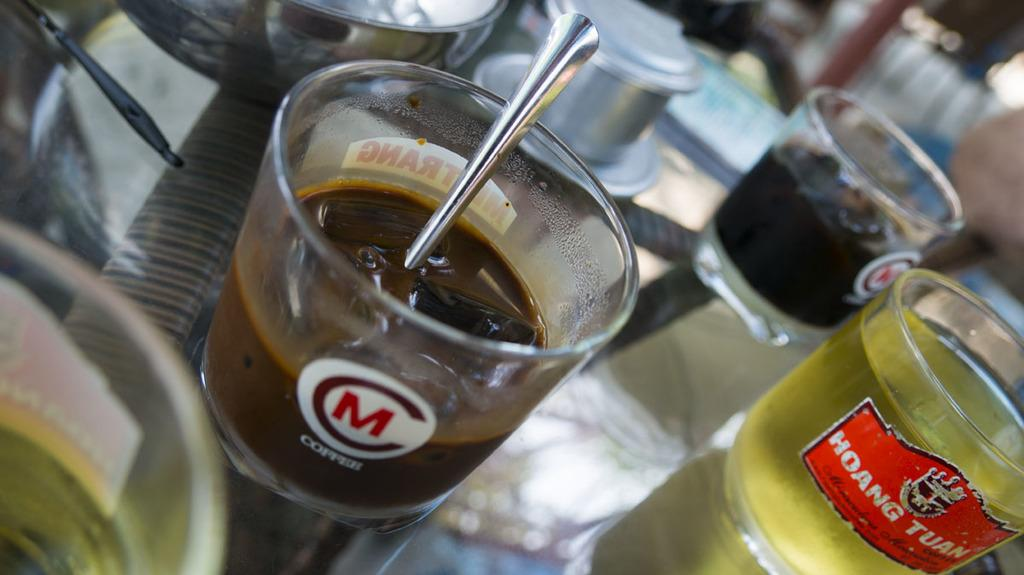<image>
Relay a brief, clear account of the picture shown. Several glasses are on a table, one reading "HOANG TUAN". 